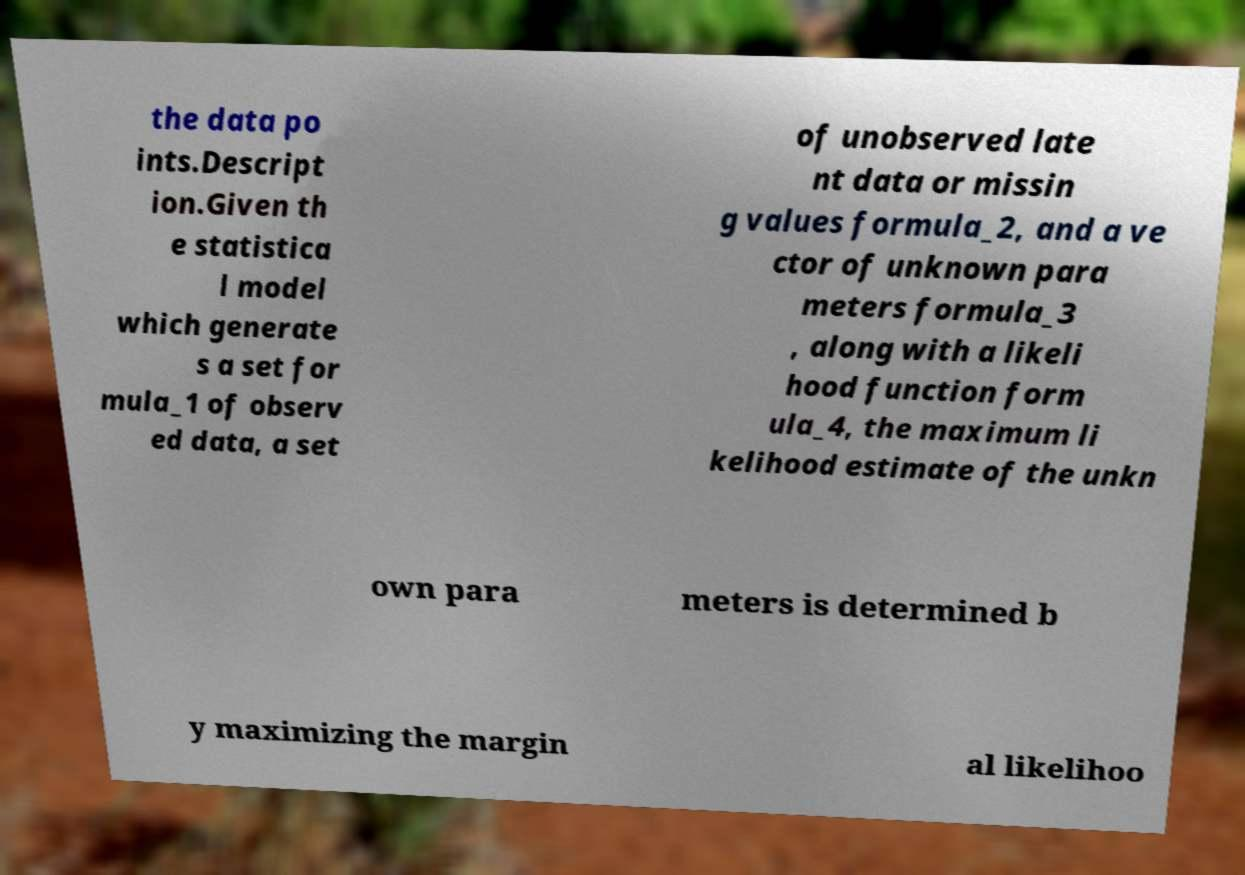Please read and relay the text visible in this image. What does it say? the data po ints.Descript ion.Given th e statistica l model which generate s a set for mula_1 of observ ed data, a set of unobserved late nt data or missin g values formula_2, and a ve ctor of unknown para meters formula_3 , along with a likeli hood function form ula_4, the maximum li kelihood estimate of the unkn own para meters is determined b y maximizing the margin al likelihoo 